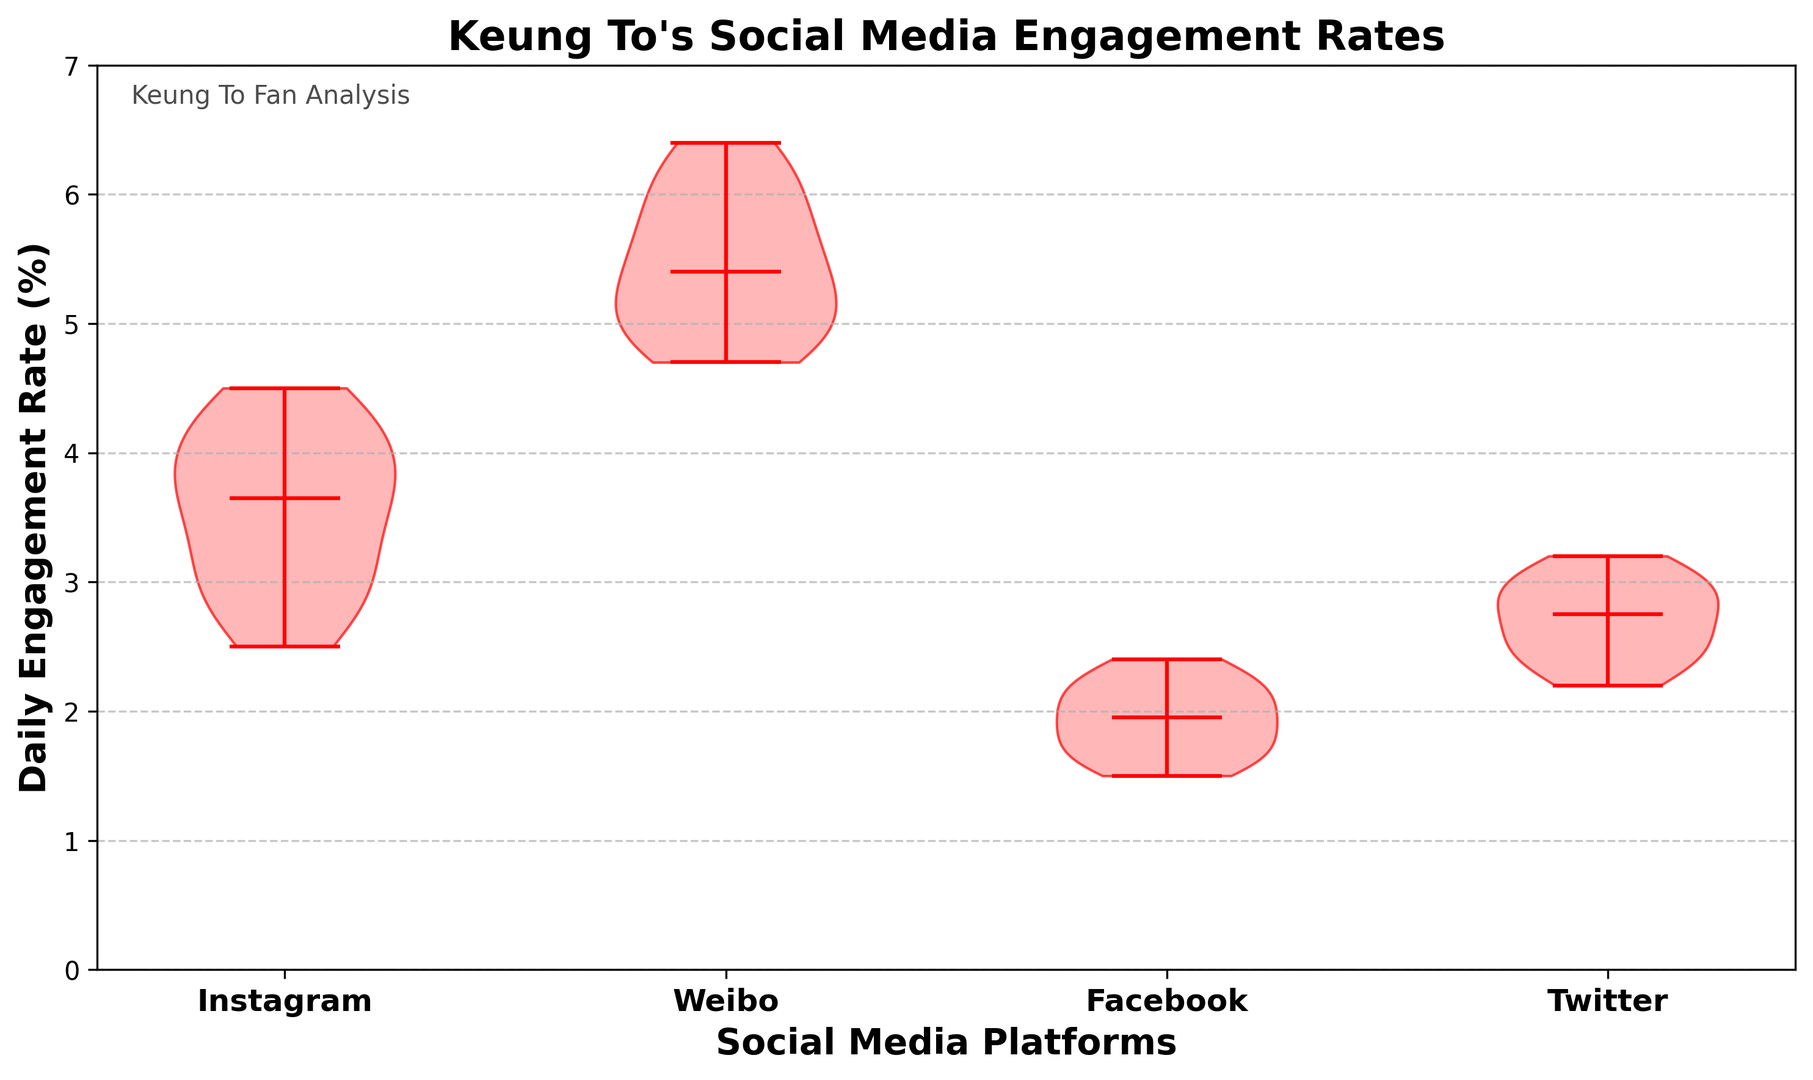What is the median engagement rate on Instagram? The median engagement rate for Instagram can be observed by looking for the middle value of the distribution in the violin plot, which is typically indicated by a central line. The median is shown as 3.7.
Answer: 3.7 Which platform has the highest median daily engagement rate? To find the platform with the highest median engagement rate, look at the central lines in each of the violins and compare their heights. Weibo has the highest central line.
Answer: Weibo Which platform has the widest range of engagement rates? To determine the widest range, compare the lengths of the violins from top to bottom. The Weibo violin is the tallest, indicating the widest range.
Answer: Weibo How do Twitter's and Facebook's median engagement rates compare? Compare the central lines in the violins for Twitter and Facebook. Twitter's median engagement rate (2.7) is higher than Facebook's median engagement rate (1.9).
Answer: Twitter's median is higher What is the approximate engagement rate range for Instagram? Look at the top and bottom tips of the Instagram violin plot. The range is from about 2.5 to 4.5.
Answer: 2.5 to 4.5 Which platform shows the lowest engagement rate? Check the lowest point of each violin plot. Facebook shows the lowest engagement rate.
Answer: Facebook How does the engagement rate distribution of Instagram compare to Twitter? Compare the shapes and spread of the violins for Instagram and Twitter. Instagram has a slightly broader distribution and higher median engagement rate compared to Twitter.
Answer: Instagram has a broader distribution and higher median How much higher is Weibo's maximum engagement rate compared to Instagram's maximum? Examine the highest points of the violins for both platforms. Weibo's maximum is around 6.4, and Instagram's maximum is around 4.5. The difference is 6.4 - 4.5 = 1.9.
Answer: 1.9 Is Facebook's engagement rate distribution more concentrated than Weibo's? Compare the widths and spread of the violins for Facebook and Weibo. Facebook's violin is narrower, indicating a more concentrated distribution.
Answer: Yes What is the median engagement rate for Twitter posts? The median engagement rate for Twitter can be found by looking at the central line in the Twitter violin. The median is 2.7.
Answer: 2.7 